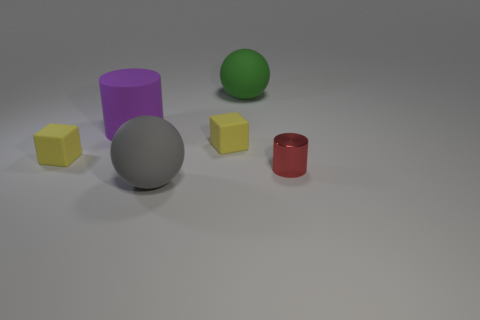Is there a big cylinder in front of the rubber cube that is on the left side of the tiny yellow cube that is to the right of the large purple rubber object?
Offer a very short reply. No. There is a cylinder that is to the right of the gray rubber ball; what is it made of?
Provide a short and direct response. Metal. What number of big objects are either red cylinders or green cylinders?
Make the answer very short. 0. Do the yellow matte cube right of the purple object and the big gray ball have the same size?
Make the answer very short. No. What number of other objects are there of the same color as the large matte cylinder?
Your response must be concise. 0. What is the material of the large gray thing?
Make the answer very short. Rubber. There is a small object that is both to the right of the large gray sphere and left of the small red metallic cylinder; what is its material?
Give a very brief answer. Rubber. What number of things are either rubber balls that are in front of the tiny red metallic cylinder or purple matte cylinders?
Keep it short and to the point. 2. Do the big matte cylinder and the small shiny cylinder have the same color?
Offer a very short reply. No. Are there any yellow cubes that have the same size as the green ball?
Give a very brief answer. No. 